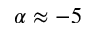<formula> <loc_0><loc_0><loc_500><loc_500>\alpha \approx - 5</formula> 